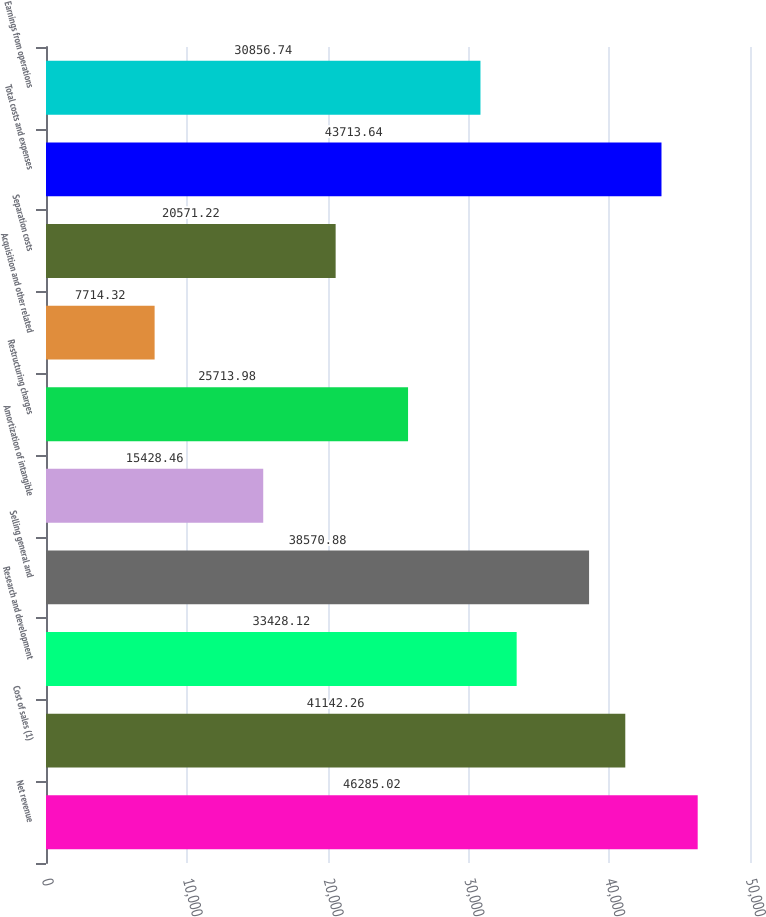<chart> <loc_0><loc_0><loc_500><loc_500><bar_chart><fcel>Net revenue<fcel>Cost of sales (1)<fcel>Research and development<fcel>Selling general and<fcel>Amortization of intangible<fcel>Restructuring charges<fcel>Acquisition and other related<fcel>Separation costs<fcel>Total costs and expenses<fcel>Earnings from operations<nl><fcel>46285<fcel>41142.3<fcel>33428.1<fcel>38570.9<fcel>15428.5<fcel>25714<fcel>7714.32<fcel>20571.2<fcel>43713.6<fcel>30856.7<nl></chart> 